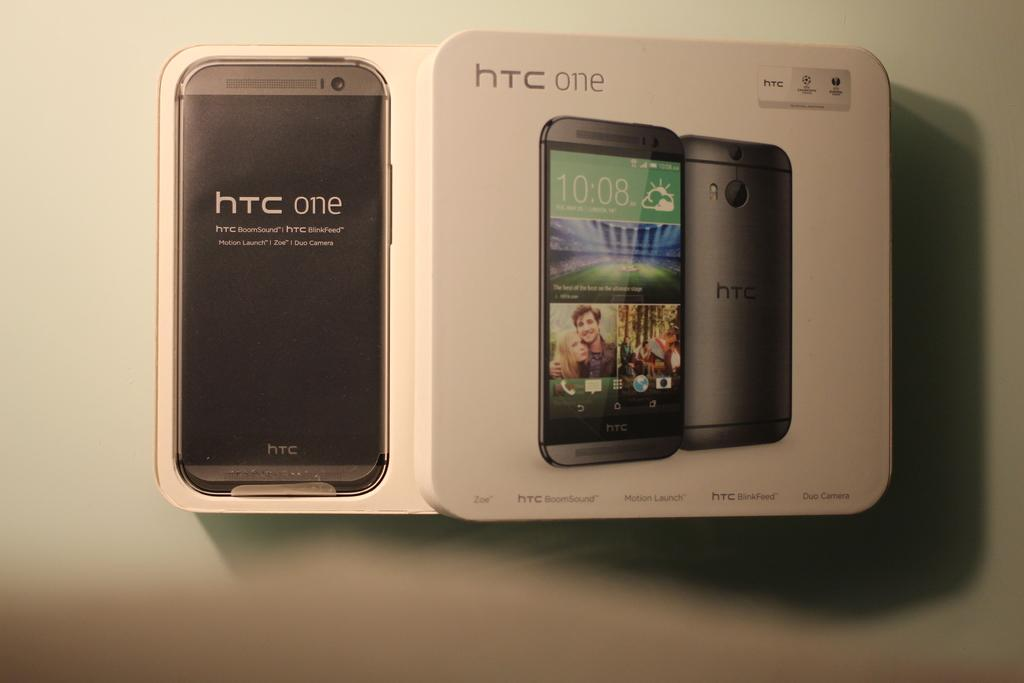<image>
Present a compact description of the photo's key features. The open box of the htc one cell phone. 